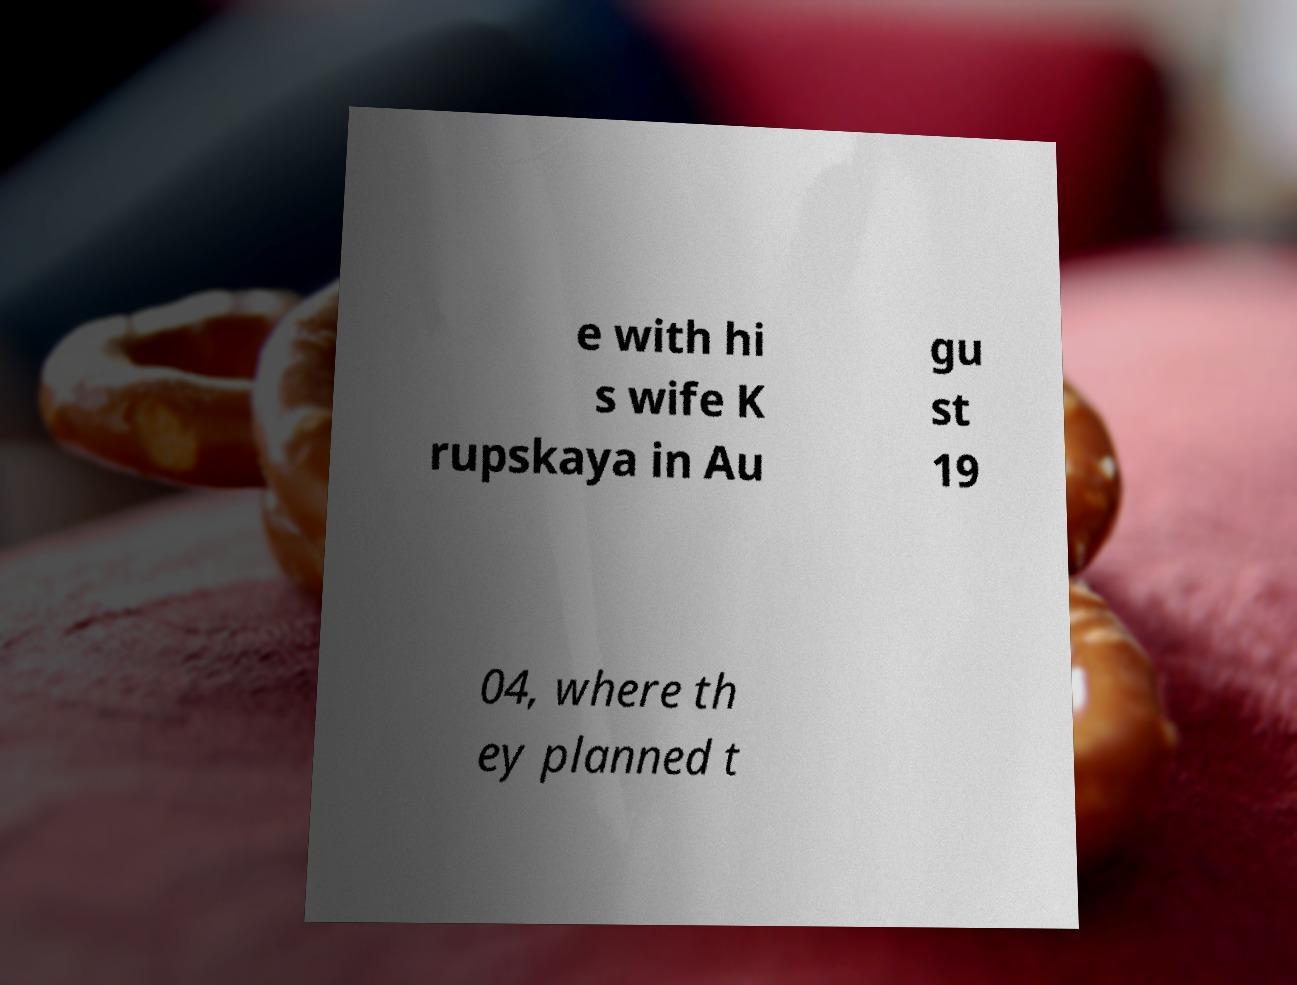I need the written content from this picture converted into text. Can you do that? e with hi s wife K rupskaya in Au gu st 19 04, where th ey planned t 